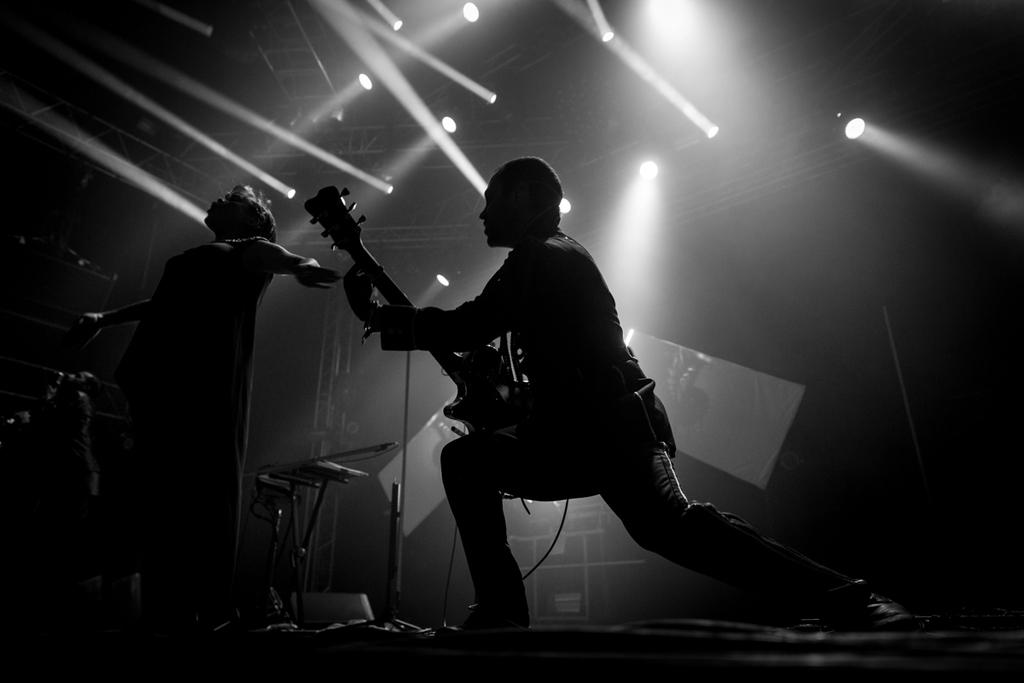What is the person holding in the image? The person is holding a guitar. What is the person's posture in the image? The person is standing. What else can be seen in the image besides the person? There are musical instruments in the image. Can you describe the roof in the image? There are holes on the roof in the image. What type of grass can be seen growing through the holes in the roof? There is no grass visible in the image; it only shows a person holding a guitar, musical instruments, and a roof with holes. 